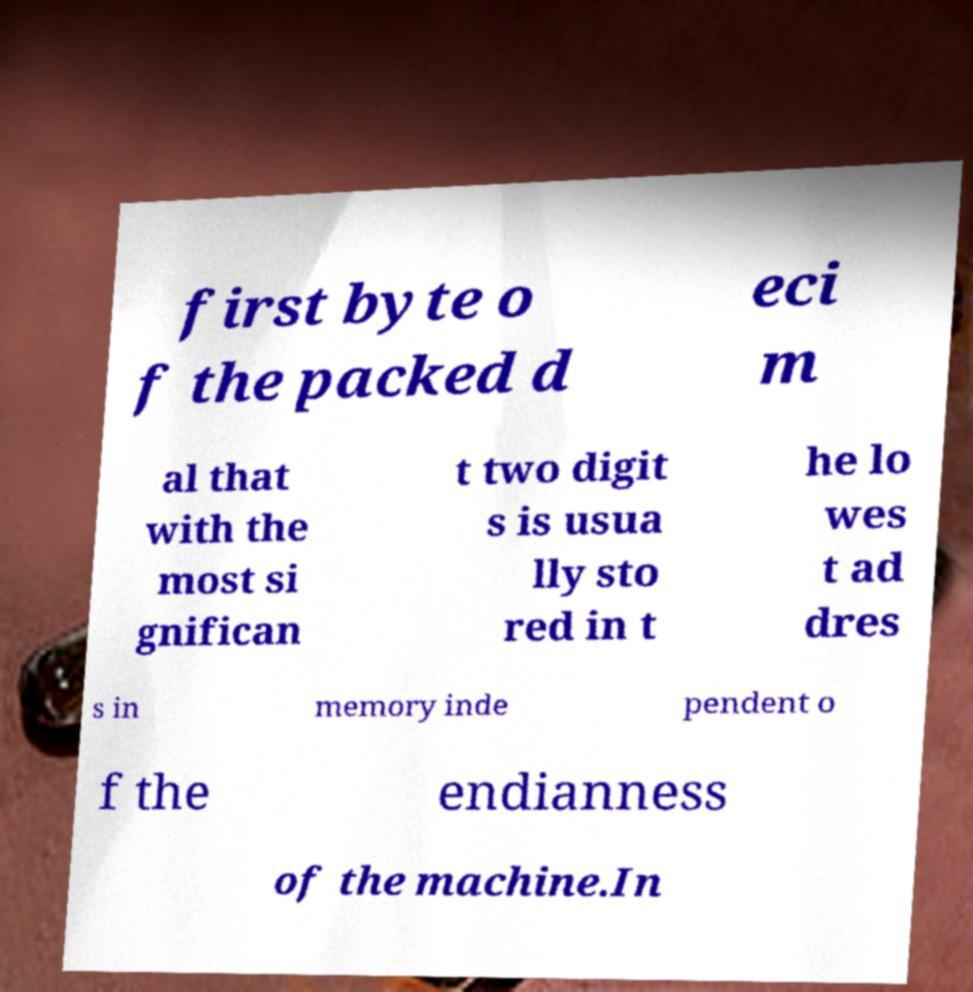I need the written content from this picture converted into text. Can you do that? first byte o f the packed d eci m al that with the most si gnifican t two digit s is usua lly sto red in t he lo wes t ad dres s in memory inde pendent o f the endianness of the machine.In 